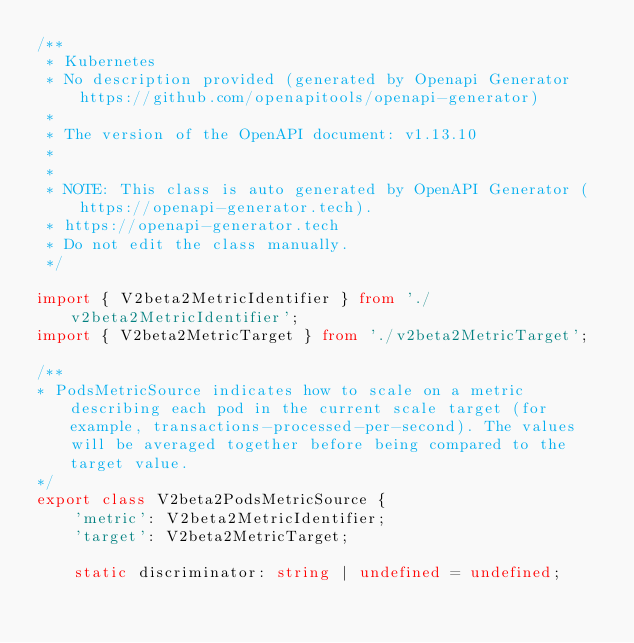Convert code to text. <code><loc_0><loc_0><loc_500><loc_500><_TypeScript_>/**
 * Kubernetes
 * No description provided (generated by Openapi Generator https://github.com/openapitools/openapi-generator)
 *
 * The version of the OpenAPI document: v1.13.10
 * 
 *
 * NOTE: This class is auto generated by OpenAPI Generator (https://openapi-generator.tech).
 * https://openapi-generator.tech
 * Do not edit the class manually.
 */

import { V2beta2MetricIdentifier } from './v2beta2MetricIdentifier';
import { V2beta2MetricTarget } from './v2beta2MetricTarget';

/**
* PodsMetricSource indicates how to scale on a metric describing each pod in the current scale target (for example, transactions-processed-per-second). The values will be averaged together before being compared to the target value.
*/
export class V2beta2PodsMetricSource {
    'metric': V2beta2MetricIdentifier;
    'target': V2beta2MetricTarget;

    static discriminator: string | undefined = undefined;
</code> 